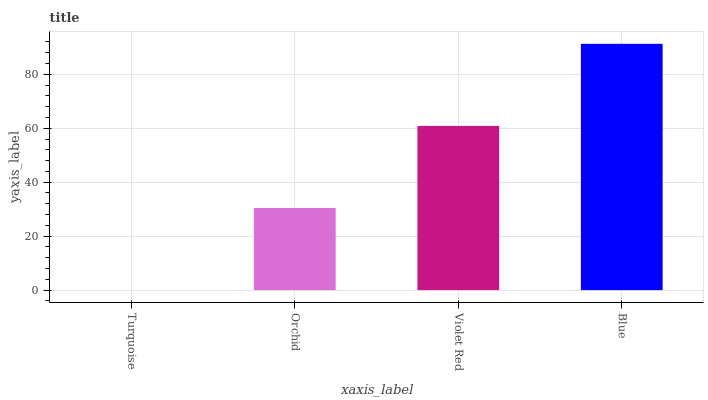Is Turquoise the minimum?
Answer yes or no. Yes. Is Blue the maximum?
Answer yes or no. Yes. Is Orchid the minimum?
Answer yes or no. No. Is Orchid the maximum?
Answer yes or no. No. Is Orchid greater than Turquoise?
Answer yes or no. Yes. Is Turquoise less than Orchid?
Answer yes or no. Yes. Is Turquoise greater than Orchid?
Answer yes or no. No. Is Orchid less than Turquoise?
Answer yes or no. No. Is Violet Red the high median?
Answer yes or no. Yes. Is Orchid the low median?
Answer yes or no. Yes. Is Orchid the high median?
Answer yes or no. No. Is Blue the low median?
Answer yes or no. No. 